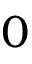Convert formula to latex. <formula><loc_0><loc_0><loc_500><loc_500>0</formula> 